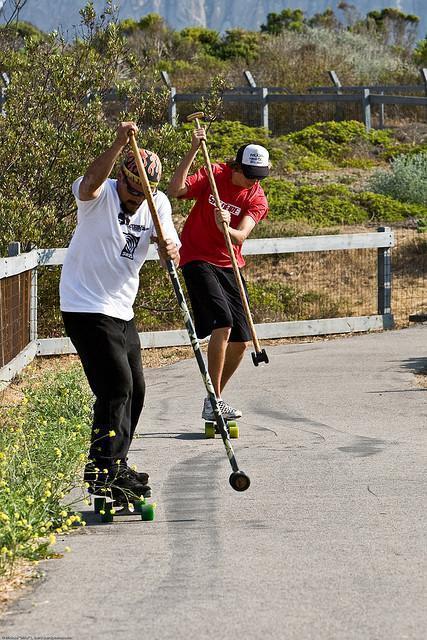What are the men riding on?
Choose the correct response and explain in the format: 'Answer: answer
Rationale: rationale.'
Options: Roller blades, scooter, skateboard, bike. Answer: skateboard.
Rationale: The men are on boards. 